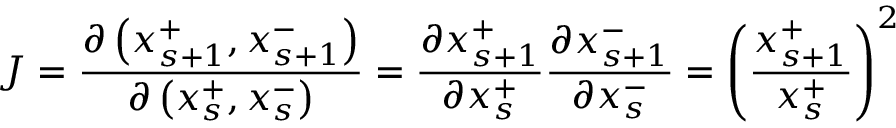Convert formula to latex. <formula><loc_0><loc_0><loc_500><loc_500>J = { \frac { \partial \left ( x _ { s + 1 } ^ { + } , x _ { s + 1 } ^ { - } \right ) } { \partial \left ( x _ { s } ^ { + } , x _ { s } ^ { - } \right ) } } = { \frac { \partial x _ { s + 1 } ^ { + } } { \partial x _ { s } ^ { + } } } { \frac { \partial x _ { s + 1 } ^ { - } } { \partial x _ { s } ^ { - } } } = \left ( { \frac { x _ { s + 1 } ^ { + } } { x _ { s } ^ { + } } } \right ) ^ { 2 }</formula> 